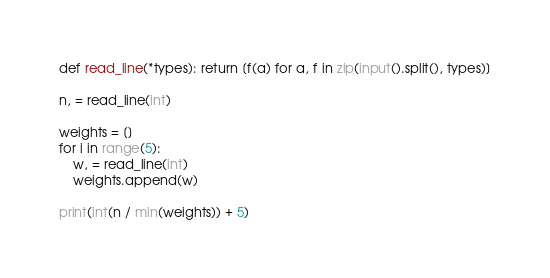Convert code to text. <code><loc_0><loc_0><loc_500><loc_500><_Python_>def read_line(*types): return [f(a) for a, f in zip(input().split(), types)]

n, = read_line(int)

weights = []
for i in range(5):
    w, = read_line(int)
    weights.append(w)

print(int(n / min(weights)) + 5)
</code> 